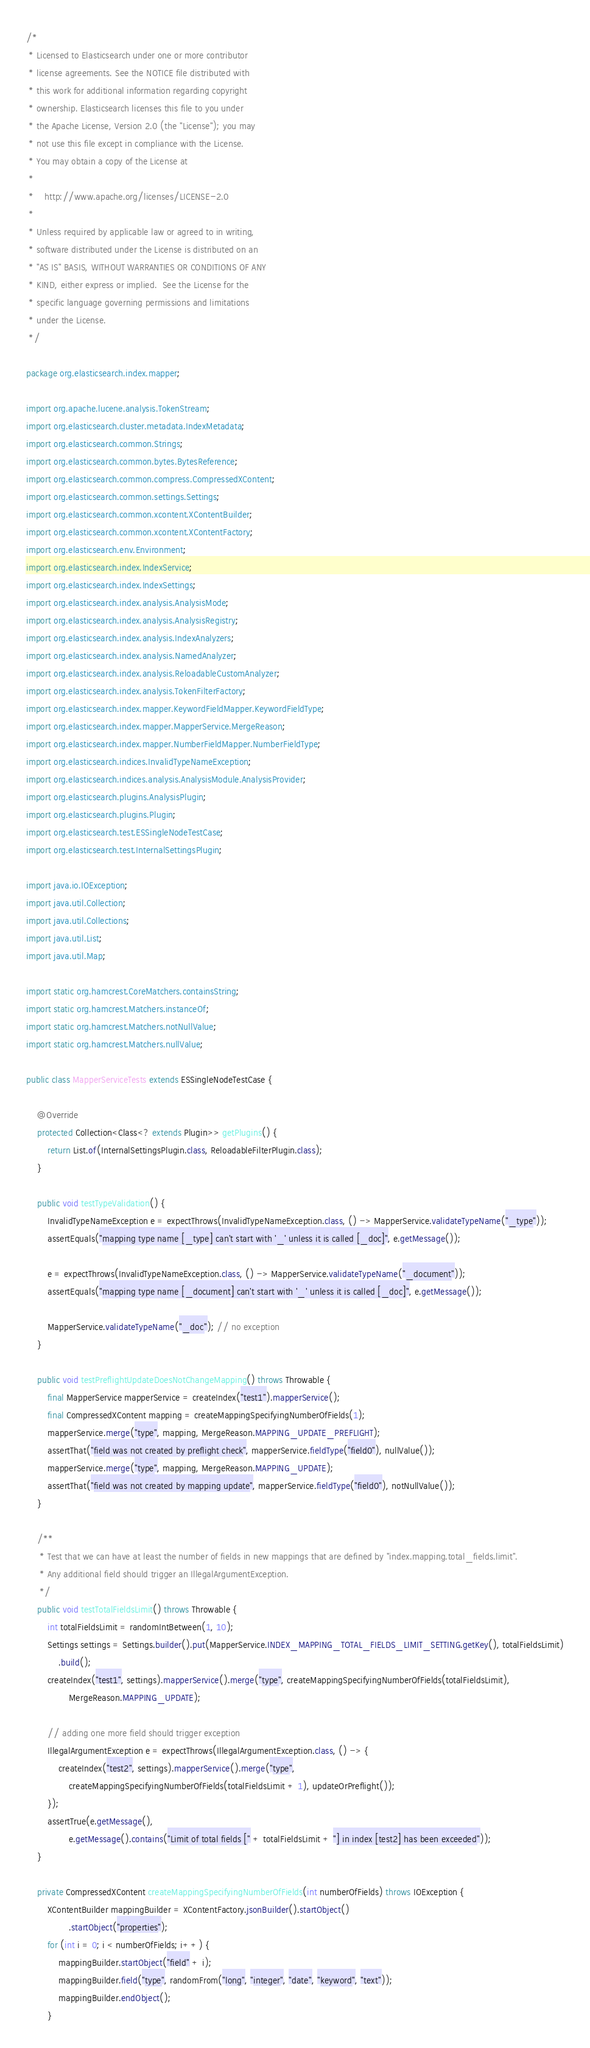<code> <loc_0><loc_0><loc_500><loc_500><_Java_>/*
 * Licensed to Elasticsearch under one or more contributor
 * license agreements. See the NOTICE file distributed with
 * this work for additional information regarding copyright
 * ownership. Elasticsearch licenses this file to you under
 * the Apache License, Version 2.0 (the "License"); you may
 * not use this file except in compliance with the License.
 * You may obtain a copy of the License at
 *
 *    http://www.apache.org/licenses/LICENSE-2.0
 *
 * Unless required by applicable law or agreed to in writing,
 * software distributed under the License is distributed on an
 * "AS IS" BASIS, WITHOUT WARRANTIES OR CONDITIONS OF ANY
 * KIND, either express or implied.  See the License for the
 * specific language governing permissions and limitations
 * under the License.
 */

package org.elasticsearch.index.mapper;

import org.apache.lucene.analysis.TokenStream;
import org.elasticsearch.cluster.metadata.IndexMetadata;
import org.elasticsearch.common.Strings;
import org.elasticsearch.common.bytes.BytesReference;
import org.elasticsearch.common.compress.CompressedXContent;
import org.elasticsearch.common.settings.Settings;
import org.elasticsearch.common.xcontent.XContentBuilder;
import org.elasticsearch.common.xcontent.XContentFactory;
import org.elasticsearch.env.Environment;
import org.elasticsearch.index.IndexService;
import org.elasticsearch.index.IndexSettings;
import org.elasticsearch.index.analysis.AnalysisMode;
import org.elasticsearch.index.analysis.AnalysisRegistry;
import org.elasticsearch.index.analysis.IndexAnalyzers;
import org.elasticsearch.index.analysis.NamedAnalyzer;
import org.elasticsearch.index.analysis.ReloadableCustomAnalyzer;
import org.elasticsearch.index.analysis.TokenFilterFactory;
import org.elasticsearch.index.mapper.KeywordFieldMapper.KeywordFieldType;
import org.elasticsearch.index.mapper.MapperService.MergeReason;
import org.elasticsearch.index.mapper.NumberFieldMapper.NumberFieldType;
import org.elasticsearch.indices.InvalidTypeNameException;
import org.elasticsearch.indices.analysis.AnalysisModule.AnalysisProvider;
import org.elasticsearch.plugins.AnalysisPlugin;
import org.elasticsearch.plugins.Plugin;
import org.elasticsearch.test.ESSingleNodeTestCase;
import org.elasticsearch.test.InternalSettingsPlugin;

import java.io.IOException;
import java.util.Collection;
import java.util.Collections;
import java.util.List;
import java.util.Map;

import static org.hamcrest.CoreMatchers.containsString;
import static org.hamcrest.Matchers.instanceOf;
import static org.hamcrest.Matchers.notNullValue;
import static org.hamcrest.Matchers.nullValue;

public class MapperServiceTests extends ESSingleNodeTestCase {

    @Override
    protected Collection<Class<? extends Plugin>> getPlugins() {
        return List.of(InternalSettingsPlugin.class, ReloadableFilterPlugin.class);
    }

    public void testTypeValidation() {
        InvalidTypeNameException e = expectThrows(InvalidTypeNameException.class, () -> MapperService.validateTypeName("_type"));
        assertEquals("mapping type name [_type] can't start with '_' unless it is called [_doc]", e.getMessage());

        e = expectThrows(InvalidTypeNameException.class, () -> MapperService.validateTypeName("_document"));
        assertEquals("mapping type name [_document] can't start with '_' unless it is called [_doc]", e.getMessage());

        MapperService.validateTypeName("_doc"); // no exception
    }

    public void testPreflightUpdateDoesNotChangeMapping() throws Throwable {
        final MapperService mapperService = createIndex("test1").mapperService();
        final CompressedXContent mapping = createMappingSpecifyingNumberOfFields(1);
        mapperService.merge("type", mapping, MergeReason.MAPPING_UPDATE_PREFLIGHT);
        assertThat("field was not created by preflight check", mapperService.fieldType("field0"), nullValue());
        mapperService.merge("type", mapping, MergeReason.MAPPING_UPDATE);
        assertThat("field was not created by mapping update", mapperService.fieldType("field0"), notNullValue());
    }

    /**
     * Test that we can have at least the number of fields in new mappings that are defined by "index.mapping.total_fields.limit".
     * Any additional field should trigger an IllegalArgumentException.
     */
    public void testTotalFieldsLimit() throws Throwable {
        int totalFieldsLimit = randomIntBetween(1, 10);
        Settings settings = Settings.builder().put(MapperService.INDEX_MAPPING_TOTAL_FIELDS_LIMIT_SETTING.getKey(), totalFieldsLimit)
            .build();
        createIndex("test1", settings).mapperService().merge("type", createMappingSpecifyingNumberOfFields(totalFieldsLimit),
                MergeReason.MAPPING_UPDATE);

        // adding one more field should trigger exception
        IllegalArgumentException e = expectThrows(IllegalArgumentException.class, () -> {
            createIndex("test2", settings).mapperService().merge("type",
                createMappingSpecifyingNumberOfFields(totalFieldsLimit + 1), updateOrPreflight());
        });
        assertTrue(e.getMessage(),
                e.getMessage().contains("Limit of total fields [" + totalFieldsLimit + "] in index [test2] has been exceeded"));
    }

    private CompressedXContent createMappingSpecifyingNumberOfFields(int numberOfFields) throws IOException {
        XContentBuilder mappingBuilder = XContentFactory.jsonBuilder().startObject()
                .startObject("properties");
        for (int i = 0; i < numberOfFields; i++) {
            mappingBuilder.startObject("field" + i);
            mappingBuilder.field("type", randomFrom("long", "integer", "date", "keyword", "text"));
            mappingBuilder.endObject();
        }</code> 